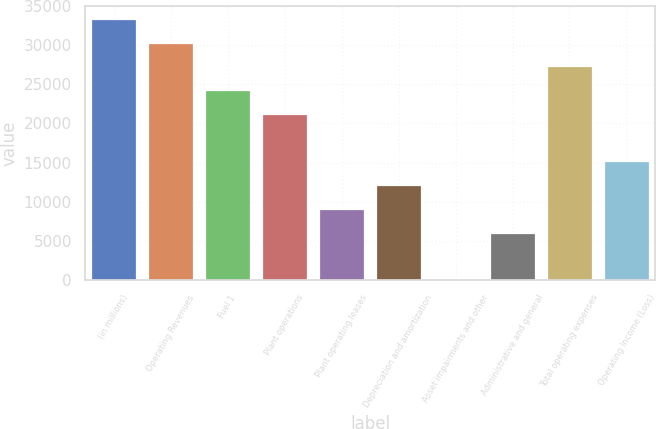Convert chart to OTSL. <chart><loc_0><loc_0><loc_500><loc_500><bar_chart><fcel>(in millions)<fcel>Operating Revenues<fcel>Fuel 1<fcel>Plant operations<fcel>Plant operating leases<fcel>Depreciation and amortization<fcel>Asset impairments and other<fcel>Administrative and general<fcel>Total operating expenses<fcel>Operating Income (Loss)<nl><fcel>33340.8<fcel>30310<fcel>24248.4<fcel>21217.6<fcel>9094.4<fcel>12125.2<fcel>2<fcel>6063.6<fcel>27279.2<fcel>15156<nl></chart> 